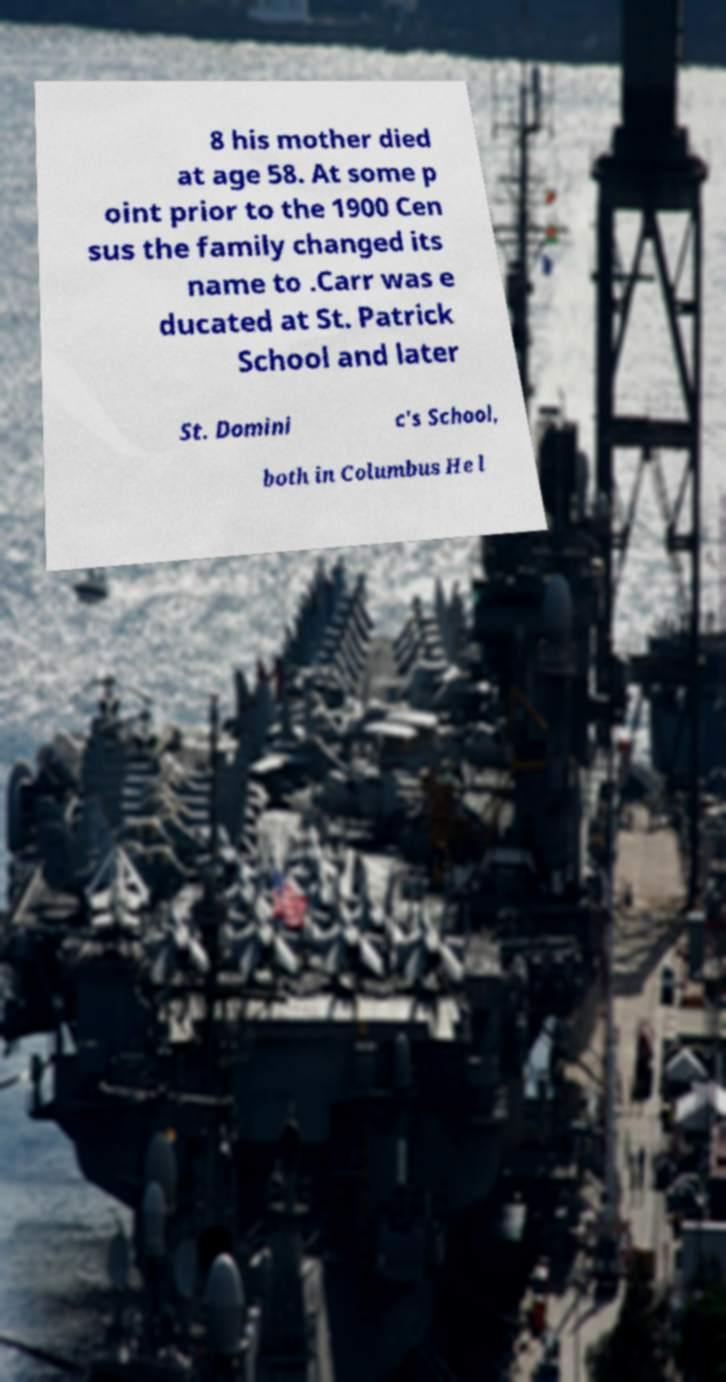What messages or text are displayed in this image? I need them in a readable, typed format. 8 his mother died at age 58. At some p oint prior to the 1900 Cen sus the family changed its name to .Carr was e ducated at St. Patrick School and later St. Domini c's School, both in Columbus He l 